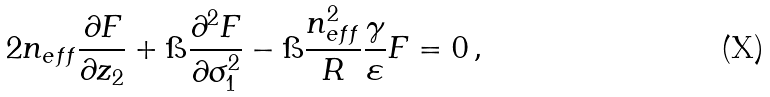<formula> <loc_0><loc_0><loc_500><loc_500>2 n _ { e f f } \frac { \partial F } { \partial z _ { 2 } } + \i \frac { \partial ^ { 2 } F } { \partial \sigma _ { 1 } ^ { 2 } } - \i \frac { n _ { e f f } ^ { 2 } } { R } \frac { \gamma } { \varepsilon } F = 0 \, ,</formula> 